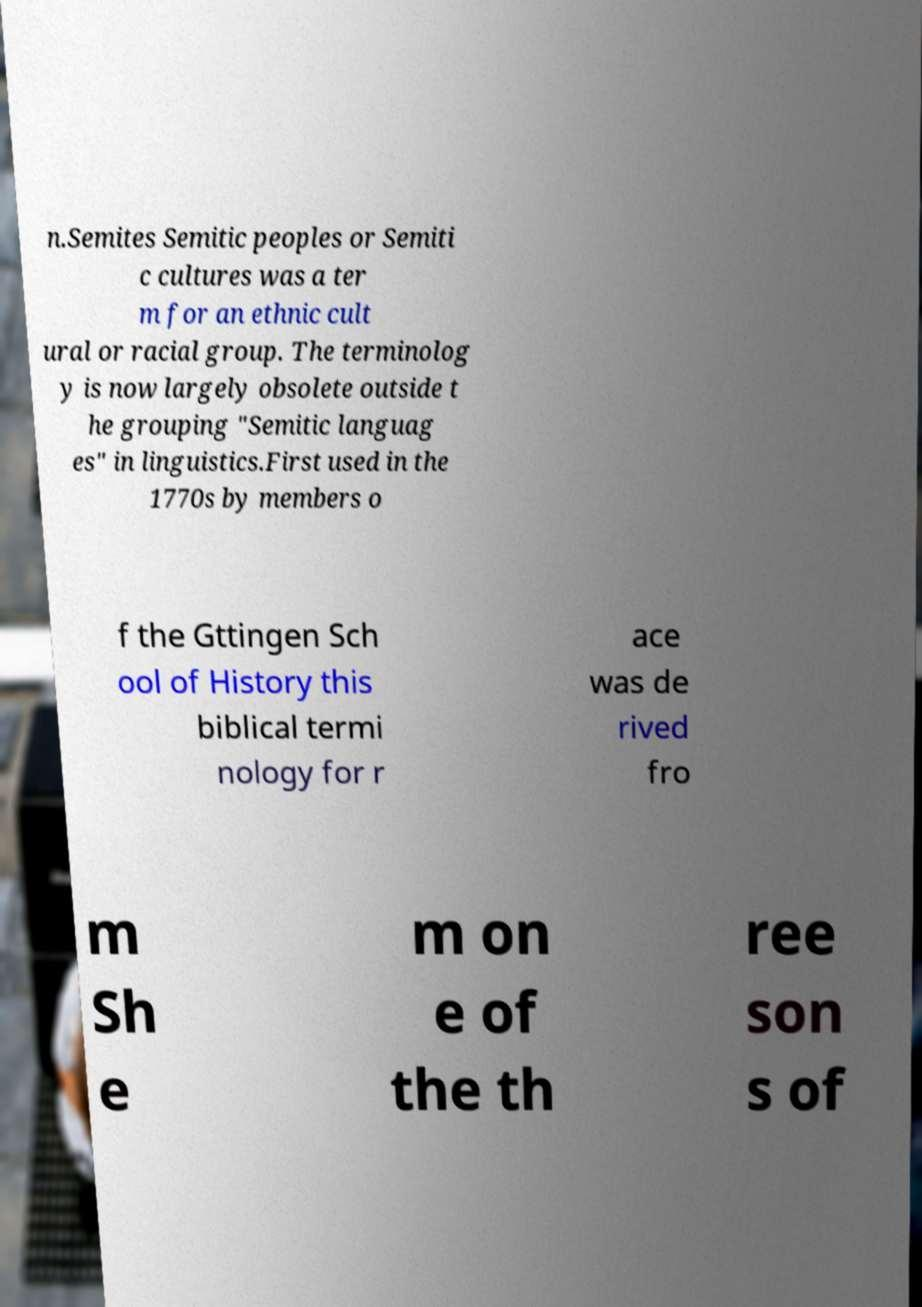There's text embedded in this image that I need extracted. Can you transcribe it verbatim? n.Semites Semitic peoples or Semiti c cultures was a ter m for an ethnic cult ural or racial group. The terminolog y is now largely obsolete outside t he grouping "Semitic languag es" in linguistics.First used in the 1770s by members o f the Gttingen Sch ool of History this biblical termi nology for r ace was de rived fro m Sh e m on e of the th ree son s of 